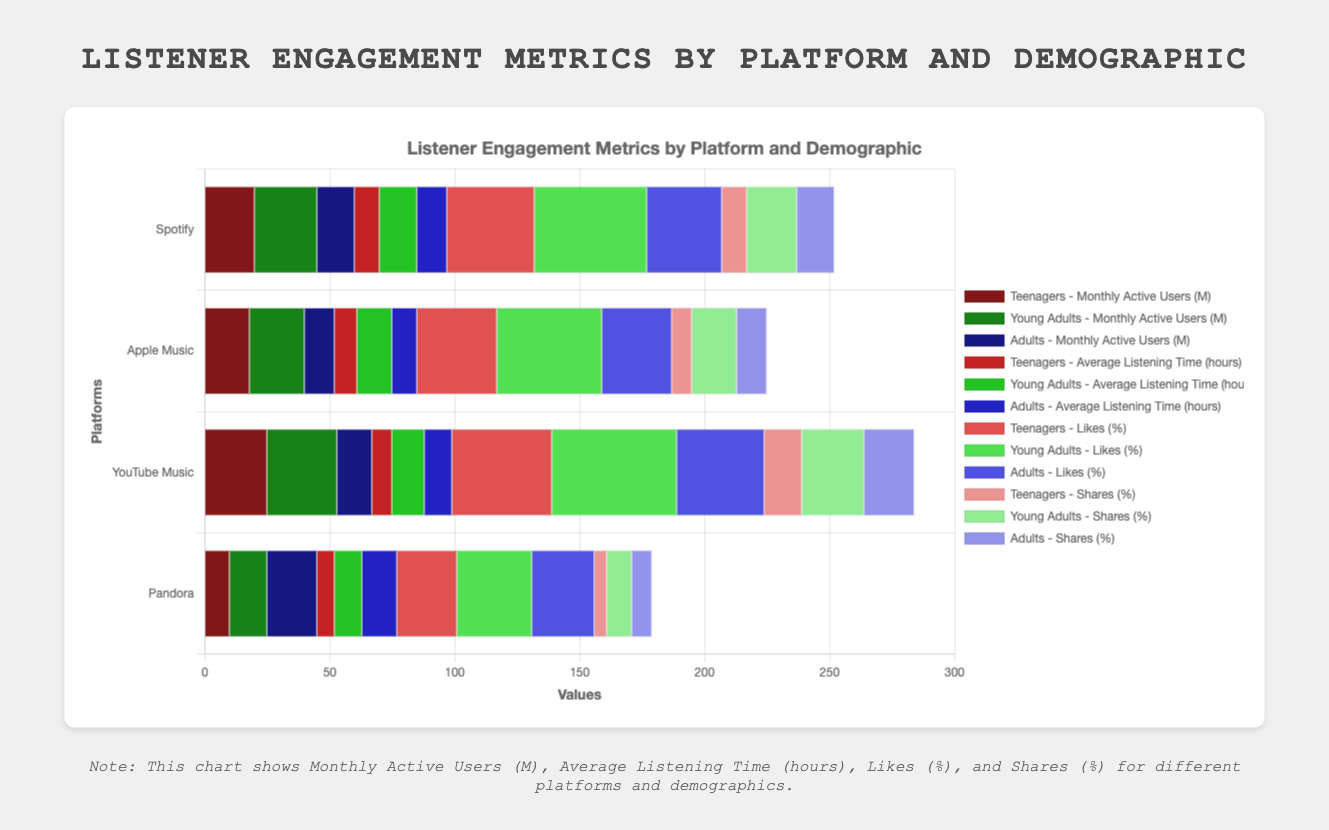What platform and demographic combination has the highest percentage of likes? Look at the "Likes (%)" across all the platforms and demographics; YouTube Music - Young Adults has the highest value at 50%.
Answer: YouTube Music - Young Adults Among adults, which platform has the longest average listening time? Compare the "Average Listening Time (hours)" for adults across all platforms; Pandora has the highest at 14 hours.
Answer: Pandora Which platform has the lowest number of monthly active users among teenagers? Check the "Monthly Active Users (M)" for teenagers across all platforms; Pandora has the lowest at 10 million.
Answer: Pandora Calculate the total number of monthly active users for YouTube Music across all demographics. Add up the "Monthly Active Users (M)" for YouTube Music across teenagers, young adults, and adults: 25+28+14=67 million.
Answer: 67 million Which demographic has the highest average listening time on Spotify? Look at the "Average Listening Time (hours)" for all demographics on Spotify; Young Adults have the highest at 15 hours.
Answer: Young Adults Compare the share percentages among young adults across all platforms. Which platform leads? Compare "Shares (%)" among young adults for all platforms; YouTube Music has the highest at 25%.
Answer: YouTube Music Which platform has the smallest variance in average listening time across all demographics? Calculate the variance in "Average Listening Time (hours)" for each platform. A detailed calculation shows that Pandora has the smallest variance.
Answer: Pandora Among adults, which two platforms have the closest average listening time? Compare "Average Listening Time (hours)" among adults across all platforms; Spotify (12 hours) and YouTube Music (11 hours) are the closest.
Answer: Spotify and YouTube Music What is the difference in the share percentage between teenagers and young adults on Apple Music? Extract "Shares (%)" for teenagers (8%) and young adults (18%) from Apple Music, then compute the difference: 18% - 8% = 10%.
Answer: 10% What platform has the highest engagement (sum of average listening time and percentage of shares) among young adults? Calculate the engagement (Average Listening Time + Shares) for each platform among young adults: Spotify=35, Apple Music=32, YouTube Music=38, Pandora=21. The highest is YouTube Music with 38.
Answer: YouTube Music 